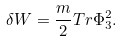<formula> <loc_0><loc_0><loc_500><loc_500>\delta W = { \frac { m } { 2 } } T r \Phi _ { 3 } ^ { 2 } .</formula> 